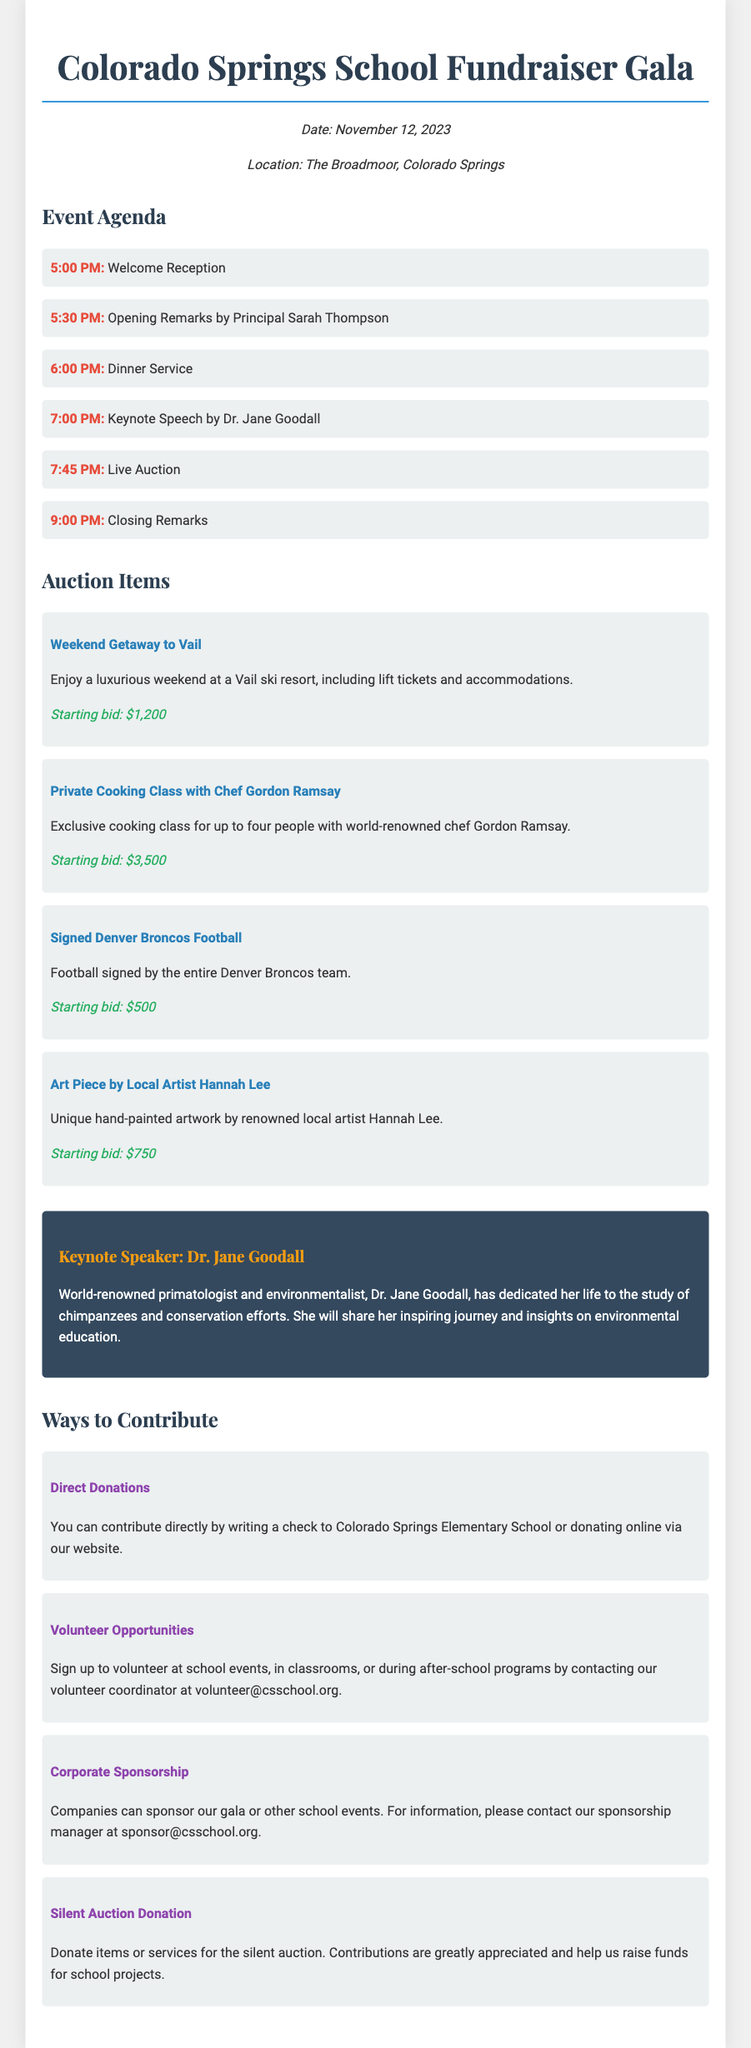What is the date of the gala? The gala is scheduled for November 12, 2023, as mentioned in the event details section.
Answer: November 12, 2023 Who is the keynote speaker? The keynote speaker listed in the document is Dr. Jane Goodall.
Answer: Dr. Jane Goodall What is the starting bid for the signed Denver Broncos football? The starting bid for the signed Denver Broncos football is specified in the auction items section.
Answer: $500 What time does the dinner service begin? The agenda outlines that dinner service starts at 6:00 PM.
Answer: 6:00 PM Which auction item has the highest starting bid? The highest starting bid among the auction items is for the Private Cooking Class with Chef Gordon Ramsay, which can be found in the auction section.
Answer: $3,500 How can individuals contribute directly to the fundraiser? The document mentions that direct contributions can be made by writing a check or donating online.
Answer: Write a check or donate online What time does the closing remarks occur? The agenda states that closing remarks are scheduled for 9:00 PM.
Answer: 9:00 PM What volunteer opportunities are mentioned? Volunteers can sign up for various roles, such as assisting at school events or classrooms, as specified in the contributions section.
Answer: School events, classrooms, after-school programs What kind of auction item is the Art Piece by Local Artist Hannah Lee? The document describes this item as a unique hand-painted artwork.
Answer: Unique hand-painted artwork 